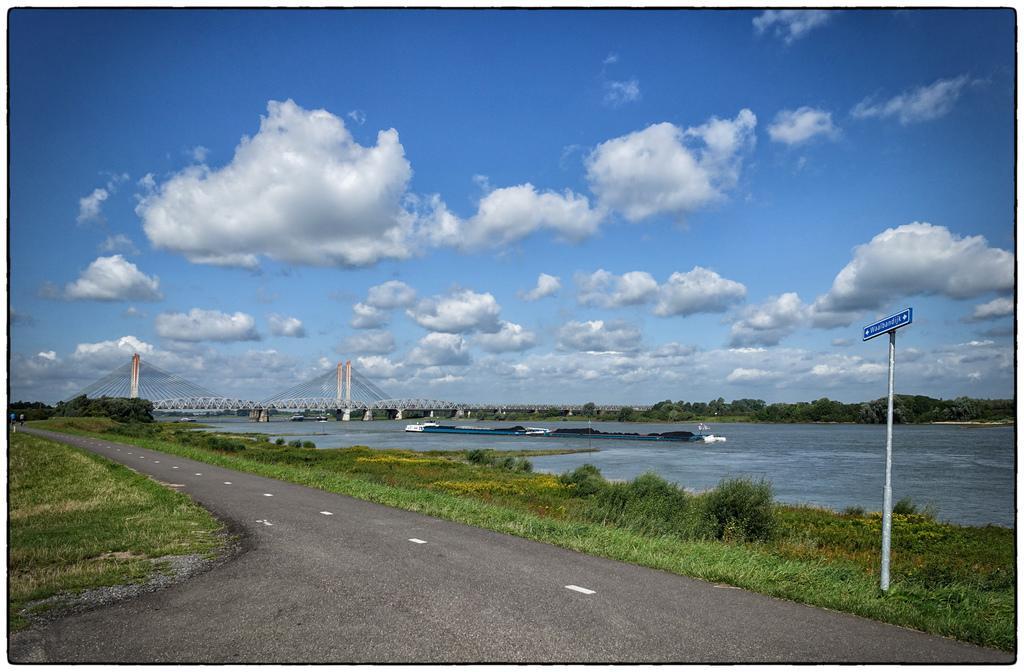How would you summarize this image in a sentence or two? In this picture we can see a road with grass on either side. On the right side, we can see the river, a bridge, a sign board and trees. The sky is blue. 